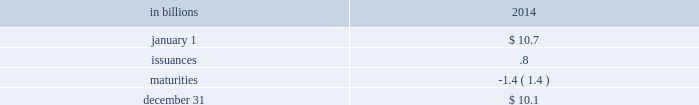On april 3 , 2014 , consistent with our 2014 capital plan , our board of directors approved an increase to pnc 2019s quarterly common stock dividend from 44 cents per common share to 48 cents per common share beginning with the may 5 , 2014 dividend payment .
In connection with the 2015 ccar , pnc submitted its 2015 capital plan , as approved by its board of directors , to the federal reserve in january 2015 .
Pnc expects to receive the federal reserve 2019s response ( either a non-objection or objection ) to the capital plan submitted as part of the 2015 ccar in march 2015 .
See the supervision and regulation section in item 1 of this report for additional information regarding the federal reserve 2019s ccar process and the factors the federal reserve takes into consideration in evaluating capital plans , qualitative and quantitative liquidity risk management standards proposed by the u.s .
Banking agencies , and final rules issued by the federal reserve that make certain modifications to the federal reserve 2019s capital planning and stress testing rules .
See table 42 for information on affiliate purchases of notes issued by pnc bank during 2014 .
On february 6 , 2015 , pnc used $ 600 million of parent company/non-bank subsidiary cash to purchase floating rate senior notes that were issued by pnc bank to an affiliate on that same date .
Parent company liquidity 2013 sources the principal source of parent company liquidity is the dividends it receives from its subsidiary bank , which may be impacted by the following : 2022 bank-level capital needs , 2022 laws and regulations , 2022 corporate policies , 2022 contractual restrictions , and 2022 other factors .
There are statutory and regulatory limitations on the ability of national banks to pay dividends or make other capital distributions or to extend credit to the parent company or its non-bank subsidiaries .
The amount available for dividend payments by pnc bank to the parent company without prior regulatory approval was approximately $ 1.5 billion at december 31 , 2014 .
See note 20 regulatory matters in the notes to consolidated financial statements in item 8 of this report for a further discussion of these limitations .
We provide additional information on certain contractual restrictions in note 12 capital securities of a subsidiary trust and perpetual trust securities in the notes to consolidated financial statements in item 8 of this report .
In addition to dividends from pnc bank , other sources of parent company liquidity include cash and investments , as well as dividends and loan repayments from other subsidiaries and dividends or distributions from equity investments .
We can also generate liquidity for the parent company and pnc 2019s non-bank subsidiaries through the issuance of debt and equity securities , including certain capital instruments , in public or private markets and commercial paper .
We have an effective shelf registration statement pursuant to which we can issue additional debt , equity and other capital instruments .
During 2014 , we issued the following parent company debt under our shelf registration statement : 2022 $ 750 million of subordinated notes with a maturity date of april 29 , 2024 .
Interest is payable semi- annually , at a fixed rate of 3.90% ( 3.90 % ) , on april 29 and october 29 of each year , beginning on october 29 , total parent company senior and subordinated debt and hybrid capital instruments decreased to $ 10.1 billion at december 31 , 2014 from $ 10.7 billion at december 31 , 2013 due to the following activity in the period .
Table 45 : parent company senior and subordinated debt and hybrid capital instruments .
On october 16 , 2014 , the parent company established a $ 5.0 billion commercial paper program to provide additional liquidity .
As of december 31 , 2014 , there were no issuances outstanding under this program .
Following the establishment of this parent company program , pnc funding corp terminated its $ 3.0 billion commercial paper program .
Note 17 equity in the notes to consolidated financial statements in item 8 of this report describes the 16885192 warrants outstanding , each to purchase one share of pnc common stock at an exercise price of $ 67.33 per share .
These warrants were sold by the u.s .
Treasury in a secondary public offering in may 2010 after the u.s .
Treasury exchanged its tarp warrant .
These warrants will expire december 31 , 2018 , and are considered in the calculation of diluted earnings per common share in note 16 earnings per share in the notes to consolidated financial statements in item 8 of this report .
Status of credit ratings the cost and availability of short-term and long-term funding , as well as collateral requirements for certain derivative instruments , is influenced by pnc 2019s debt ratings .
In general , rating agencies base their ratings on many quantitative and qualitative factors , including capital adequacy , liquidity , asset quality , business mix , level and quality of earnings , and the current legislative and regulatory environment , including implied government support .
In the pnc financial services group , inc .
2013 form 10-k 89 .
By how much did total parent company senior and subordinated debt and hybrid capital instruments decreased at december 31 , 2014 from december 31 , 2013 , in billions? 
Computations: (10.7 - 10.1)
Answer: 0.6. 